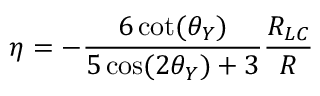Convert formula to latex. <formula><loc_0><loc_0><loc_500><loc_500>\eta = - \frac { 6 \cot ( \theta _ { Y } ) } { 5 \cos ( 2 \theta _ { Y } ) + 3 } \frac { R _ { L C } } { R }</formula> 